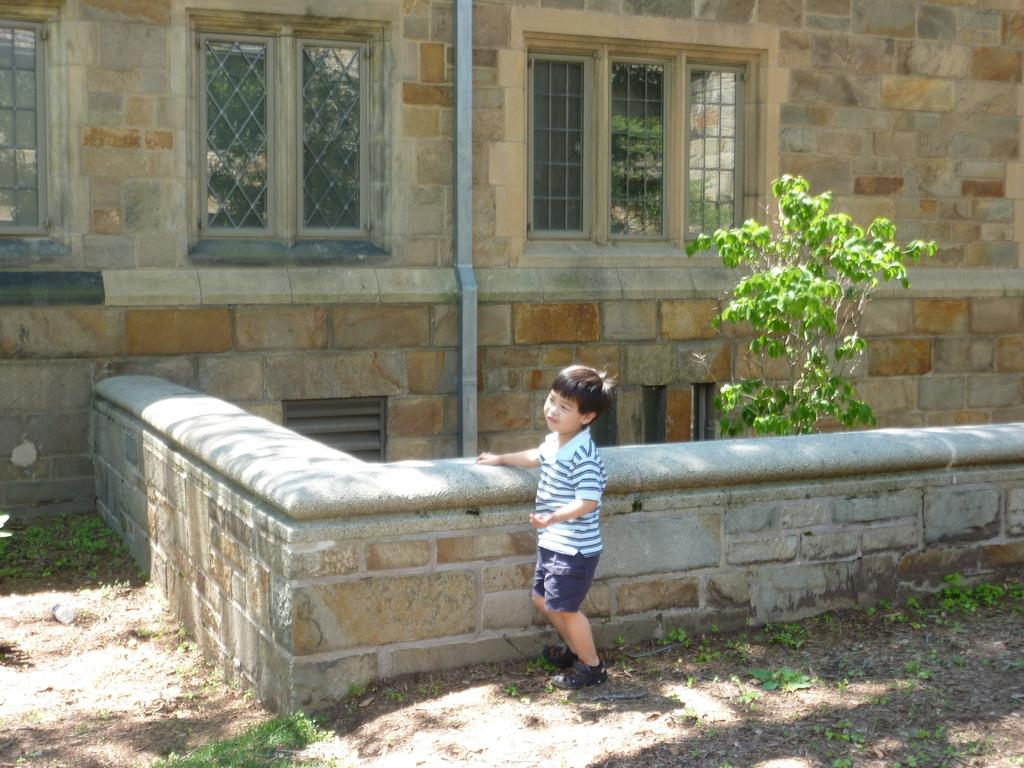Who is the main subject in the image? There is a boy in the image. Where is the boy standing? The boy is standing on a path. What is visible behind the boy? There is a wall, a tree, and a building behind the boy. Can you describe the building in the image? The building has windows and a pipe. Where is the boy's mom in the image? There is no information about the boy's mom in the image, so we cannot determine her location. What type of animals can be seen at the zoo in the image? There is no zoo present in the image, so we cannot determine what type of animals might be there. 